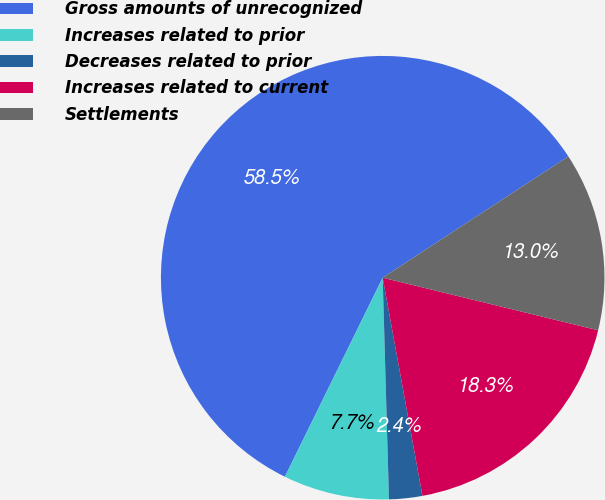<chart> <loc_0><loc_0><loc_500><loc_500><pie_chart><fcel>Gross amounts of unrecognized<fcel>Increases related to prior<fcel>Decreases related to prior<fcel>Increases related to current<fcel>Settlements<nl><fcel>58.53%<fcel>7.72%<fcel>2.42%<fcel>18.32%<fcel>13.02%<nl></chart> 